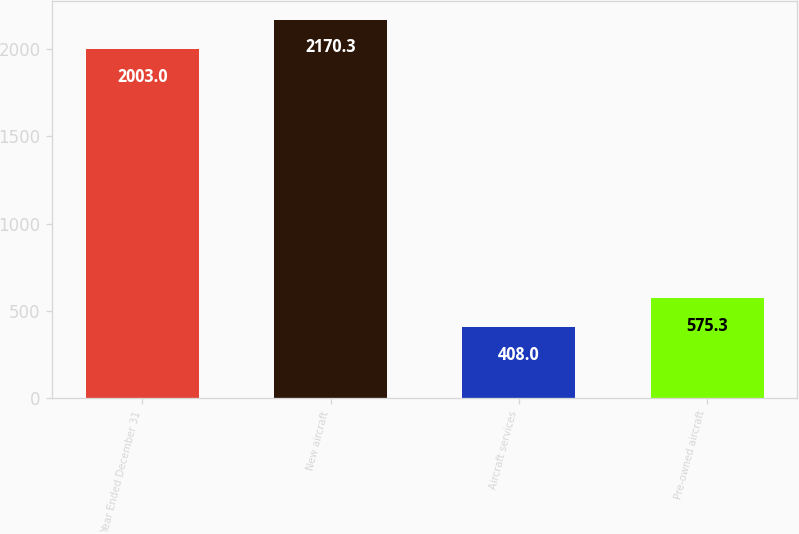<chart> <loc_0><loc_0><loc_500><loc_500><bar_chart><fcel>Year Ended December 31<fcel>New aircraft<fcel>Aircraft services<fcel>Pre-owned aircraft<nl><fcel>2003<fcel>2170.3<fcel>408<fcel>575.3<nl></chart> 